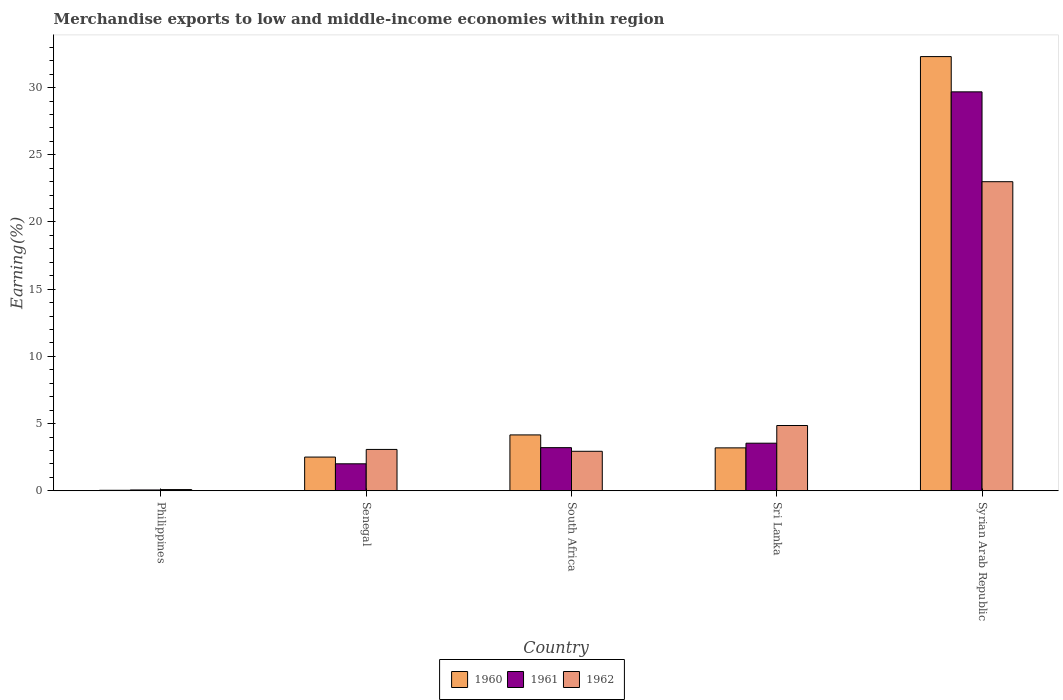How many different coloured bars are there?
Provide a short and direct response. 3. Are the number of bars per tick equal to the number of legend labels?
Your answer should be compact. Yes. Are the number of bars on each tick of the X-axis equal?
Provide a short and direct response. Yes. How many bars are there on the 5th tick from the left?
Your answer should be very brief. 3. How many bars are there on the 5th tick from the right?
Offer a very short reply. 3. What is the label of the 1st group of bars from the left?
Offer a terse response. Philippines. In how many cases, is the number of bars for a given country not equal to the number of legend labels?
Your answer should be compact. 0. What is the percentage of amount earned from merchandise exports in 1960 in South Africa?
Make the answer very short. 4.16. Across all countries, what is the maximum percentage of amount earned from merchandise exports in 1960?
Ensure brevity in your answer.  32.31. Across all countries, what is the minimum percentage of amount earned from merchandise exports in 1962?
Your answer should be very brief. 0.09. In which country was the percentage of amount earned from merchandise exports in 1962 maximum?
Ensure brevity in your answer.  Syrian Arab Republic. What is the total percentage of amount earned from merchandise exports in 1962 in the graph?
Provide a succinct answer. 33.96. What is the difference between the percentage of amount earned from merchandise exports in 1960 in Philippines and that in Sri Lanka?
Keep it short and to the point. -3.16. What is the difference between the percentage of amount earned from merchandise exports in 1960 in South Africa and the percentage of amount earned from merchandise exports in 1962 in Senegal?
Offer a terse response. 1.08. What is the average percentage of amount earned from merchandise exports in 1960 per country?
Make the answer very short. 8.44. What is the difference between the percentage of amount earned from merchandise exports of/in 1961 and percentage of amount earned from merchandise exports of/in 1960 in South Africa?
Your answer should be compact. -0.95. In how many countries, is the percentage of amount earned from merchandise exports in 1960 greater than 28 %?
Give a very brief answer. 1. What is the ratio of the percentage of amount earned from merchandise exports in 1961 in Philippines to that in Syrian Arab Republic?
Ensure brevity in your answer.  0. Is the percentage of amount earned from merchandise exports in 1960 in Senegal less than that in Syrian Arab Republic?
Your response must be concise. Yes. What is the difference between the highest and the second highest percentage of amount earned from merchandise exports in 1961?
Give a very brief answer. -0.33. What is the difference between the highest and the lowest percentage of amount earned from merchandise exports in 1960?
Offer a very short reply. 32.27. In how many countries, is the percentage of amount earned from merchandise exports in 1962 greater than the average percentage of amount earned from merchandise exports in 1962 taken over all countries?
Offer a terse response. 1. What does the 2nd bar from the left in Syrian Arab Republic represents?
Give a very brief answer. 1961. What does the 2nd bar from the right in Syrian Arab Republic represents?
Provide a succinct answer. 1961. Are all the bars in the graph horizontal?
Make the answer very short. No. How many countries are there in the graph?
Provide a succinct answer. 5. Does the graph contain any zero values?
Make the answer very short. No. Does the graph contain grids?
Give a very brief answer. No. How many legend labels are there?
Offer a terse response. 3. How are the legend labels stacked?
Your response must be concise. Horizontal. What is the title of the graph?
Keep it short and to the point. Merchandise exports to low and middle-income economies within region. What is the label or title of the Y-axis?
Offer a very short reply. Earning(%). What is the Earning(%) of 1960 in Philippines?
Offer a terse response. 0.04. What is the Earning(%) of 1961 in Philippines?
Offer a terse response. 0.06. What is the Earning(%) of 1962 in Philippines?
Provide a short and direct response. 0.09. What is the Earning(%) of 1960 in Senegal?
Give a very brief answer. 2.51. What is the Earning(%) of 1961 in Senegal?
Make the answer very short. 2.01. What is the Earning(%) in 1962 in Senegal?
Keep it short and to the point. 3.08. What is the Earning(%) of 1960 in South Africa?
Your response must be concise. 4.16. What is the Earning(%) of 1961 in South Africa?
Offer a very short reply. 3.21. What is the Earning(%) of 1962 in South Africa?
Provide a short and direct response. 2.94. What is the Earning(%) in 1960 in Sri Lanka?
Offer a very short reply. 3.19. What is the Earning(%) of 1961 in Sri Lanka?
Give a very brief answer. 3.54. What is the Earning(%) of 1962 in Sri Lanka?
Offer a terse response. 4.86. What is the Earning(%) in 1960 in Syrian Arab Republic?
Provide a short and direct response. 32.31. What is the Earning(%) of 1961 in Syrian Arab Republic?
Make the answer very short. 29.68. What is the Earning(%) in 1962 in Syrian Arab Republic?
Your answer should be very brief. 23. Across all countries, what is the maximum Earning(%) of 1960?
Provide a succinct answer. 32.31. Across all countries, what is the maximum Earning(%) of 1961?
Provide a succinct answer. 29.68. Across all countries, what is the maximum Earning(%) of 1962?
Provide a succinct answer. 23. Across all countries, what is the minimum Earning(%) in 1960?
Provide a succinct answer. 0.04. Across all countries, what is the minimum Earning(%) of 1961?
Your answer should be very brief. 0.06. Across all countries, what is the minimum Earning(%) of 1962?
Your answer should be compact. 0.09. What is the total Earning(%) in 1960 in the graph?
Keep it short and to the point. 42.2. What is the total Earning(%) in 1961 in the graph?
Provide a short and direct response. 38.5. What is the total Earning(%) in 1962 in the graph?
Offer a very short reply. 33.96. What is the difference between the Earning(%) in 1960 in Philippines and that in Senegal?
Your response must be concise. -2.47. What is the difference between the Earning(%) of 1961 in Philippines and that in Senegal?
Provide a succinct answer. -1.95. What is the difference between the Earning(%) of 1962 in Philippines and that in Senegal?
Provide a succinct answer. -2.99. What is the difference between the Earning(%) in 1960 in Philippines and that in South Africa?
Give a very brief answer. -4.12. What is the difference between the Earning(%) in 1961 in Philippines and that in South Africa?
Give a very brief answer. -3.15. What is the difference between the Earning(%) of 1962 in Philippines and that in South Africa?
Keep it short and to the point. -2.85. What is the difference between the Earning(%) of 1960 in Philippines and that in Sri Lanka?
Your answer should be compact. -3.16. What is the difference between the Earning(%) of 1961 in Philippines and that in Sri Lanka?
Make the answer very short. -3.48. What is the difference between the Earning(%) of 1962 in Philippines and that in Sri Lanka?
Offer a very short reply. -4.77. What is the difference between the Earning(%) in 1960 in Philippines and that in Syrian Arab Republic?
Give a very brief answer. -32.27. What is the difference between the Earning(%) of 1961 in Philippines and that in Syrian Arab Republic?
Give a very brief answer. -29.62. What is the difference between the Earning(%) of 1962 in Philippines and that in Syrian Arab Republic?
Give a very brief answer. -22.91. What is the difference between the Earning(%) of 1960 in Senegal and that in South Africa?
Your answer should be very brief. -1.65. What is the difference between the Earning(%) in 1961 in Senegal and that in South Africa?
Your answer should be very brief. -1.2. What is the difference between the Earning(%) of 1962 in Senegal and that in South Africa?
Ensure brevity in your answer.  0.14. What is the difference between the Earning(%) of 1960 in Senegal and that in Sri Lanka?
Offer a terse response. -0.68. What is the difference between the Earning(%) in 1961 in Senegal and that in Sri Lanka?
Your answer should be very brief. -1.53. What is the difference between the Earning(%) of 1962 in Senegal and that in Sri Lanka?
Offer a terse response. -1.78. What is the difference between the Earning(%) in 1960 in Senegal and that in Syrian Arab Republic?
Your response must be concise. -29.8. What is the difference between the Earning(%) of 1961 in Senegal and that in Syrian Arab Republic?
Your response must be concise. -27.68. What is the difference between the Earning(%) in 1962 in Senegal and that in Syrian Arab Republic?
Ensure brevity in your answer.  -19.92. What is the difference between the Earning(%) in 1960 in South Africa and that in Sri Lanka?
Provide a short and direct response. 0.96. What is the difference between the Earning(%) in 1961 in South Africa and that in Sri Lanka?
Provide a succinct answer. -0.33. What is the difference between the Earning(%) in 1962 in South Africa and that in Sri Lanka?
Provide a short and direct response. -1.92. What is the difference between the Earning(%) in 1960 in South Africa and that in Syrian Arab Republic?
Provide a short and direct response. -28.15. What is the difference between the Earning(%) of 1961 in South Africa and that in Syrian Arab Republic?
Provide a short and direct response. -26.47. What is the difference between the Earning(%) of 1962 in South Africa and that in Syrian Arab Republic?
Make the answer very short. -20.06. What is the difference between the Earning(%) in 1960 in Sri Lanka and that in Syrian Arab Republic?
Your response must be concise. -29.11. What is the difference between the Earning(%) in 1961 in Sri Lanka and that in Syrian Arab Republic?
Ensure brevity in your answer.  -26.14. What is the difference between the Earning(%) of 1962 in Sri Lanka and that in Syrian Arab Republic?
Your answer should be very brief. -18.14. What is the difference between the Earning(%) of 1960 in Philippines and the Earning(%) of 1961 in Senegal?
Provide a short and direct response. -1.97. What is the difference between the Earning(%) of 1960 in Philippines and the Earning(%) of 1962 in Senegal?
Keep it short and to the point. -3.04. What is the difference between the Earning(%) of 1961 in Philippines and the Earning(%) of 1962 in Senegal?
Give a very brief answer. -3.02. What is the difference between the Earning(%) in 1960 in Philippines and the Earning(%) in 1961 in South Africa?
Give a very brief answer. -3.17. What is the difference between the Earning(%) of 1960 in Philippines and the Earning(%) of 1962 in South Africa?
Offer a very short reply. -2.9. What is the difference between the Earning(%) of 1961 in Philippines and the Earning(%) of 1962 in South Africa?
Make the answer very short. -2.88. What is the difference between the Earning(%) of 1960 in Philippines and the Earning(%) of 1961 in Sri Lanka?
Give a very brief answer. -3.5. What is the difference between the Earning(%) of 1960 in Philippines and the Earning(%) of 1962 in Sri Lanka?
Provide a short and direct response. -4.82. What is the difference between the Earning(%) of 1961 in Philippines and the Earning(%) of 1962 in Sri Lanka?
Your response must be concise. -4.8. What is the difference between the Earning(%) in 1960 in Philippines and the Earning(%) in 1961 in Syrian Arab Republic?
Offer a terse response. -29.65. What is the difference between the Earning(%) in 1960 in Philippines and the Earning(%) in 1962 in Syrian Arab Republic?
Your response must be concise. -22.96. What is the difference between the Earning(%) in 1961 in Philippines and the Earning(%) in 1962 in Syrian Arab Republic?
Keep it short and to the point. -22.94. What is the difference between the Earning(%) of 1960 in Senegal and the Earning(%) of 1961 in South Africa?
Your response must be concise. -0.7. What is the difference between the Earning(%) of 1960 in Senegal and the Earning(%) of 1962 in South Africa?
Ensure brevity in your answer.  -0.43. What is the difference between the Earning(%) in 1961 in Senegal and the Earning(%) in 1962 in South Africa?
Keep it short and to the point. -0.93. What is the difference between the Earning(%) of 1960 in Senegal and the Earning(%) of 1961 in Sri Lanka?
Your answer should be compact. -1.03. What is the difference between the Earning(%) in 1960 in Senegal and the Earning(%) in 1962 in Sri Lanka?
Ensure brevity in your answer.  -2.35. What is the difference between the Earning(%) of 1961 in Senegal and the Earning(%) of 1962 in Sri Lanka?
Provide a short and direct response. -2.85. What is the difference between the Earning(%) of 1960 in Senegal and the Earning(%) of 1961 in Syrian Arab Republic?
Your answer should be compact. -27.17. What is the difference between the Earning(%) in 1960 in Senegal and the Earning(%) in 1962 in Syrian Arab Republic?
Your answer should be compact. -20.49. What is the difference between the Earning(%) in 1961 in Senegal and the Earning(%) in 1962 in Syrian Arab Republic?
Your answer should be compact. -20.99. What is the difference between the Earning(%) in 1960 in South Africa and the Earning(%) in 1961 in Sri Lanka?
Ensure brevity in your answer.  0.62. What is the difference between the Earning(%) of 1960 in South Africa and the Earning(%) of 1962 in Sri Lanka?
Provide a succinct answer. -0.7. What is the difference between the Earning(%) in 1961 in South Africa and the Earning(%) in 1962 in Sri Lanka?
Give a very brief answer. -1.65. What is the difference between the Earning(%) of 1960 in South Africa and the Earning(%) of 1961 in Syrian Arab Republic?
Your response must be concise. -25.53. What is the difference between the Earning(%) in 1960 in South Africa and the Earning(%) in 1962 in Syrian Arab Republic?
Your answer should be compact. -18.84. What is the difference between the Earning(%) of 1961 in South Africa and the Earning(%) of 1962 in Syrian Arab Republic?
Ensure brevity in your answer.  -19.79. What is the difference between the Earning(%) in 1960 in Sri Lanka and the Earning(%) in 1961 in Syrian Arab Republic?
Make the answer very short. -26.49. What is the difference between the Earning(%) in 1960 in Sri Lanka and the Earning(%) in 1962 in Syrian Arab Republic?
Keep it short and to the point. -19.8. What is the difference between the Earning(%) in 1961 in Sri Lanka and the Earning(%) in 1962 in Syrian Arab Republic?
Your answer should be compact. -19.46. What is the average Earning(%) of 1960 per country?
Your answer should be compact. 8.44. What is the average Earning(%) in 1961 per country?
Give a very brief answer. 7.7. What is the average Earning(%) of 1962 per country?
Make the answer very short. 6.79. What is the difference between the Earning(%) of 1960 and Earning(%) of 1961 in Philippines?
Offer a very short reply. -0.02. What is the difference between the Earning(%) in 1960 and Earning(%) in 1962 in Philippines?
Your response must be concise. -0.05. What is the difference between the Earning(%) of 1961 and Earning(%) of 1962 in Philippines?
Your answer should be very brief. -0.03. What is the difference between the Earning(%) of 1960 and Earning(%) of 1961 in Senegal?
Make the answer very short. 0.5. What is the difference between the Earning(%) in 1960 and Earning(%) in 1962 in Senegal?
Give a very brief answer. -0.57. What is the difference between the Earning(%) of 1961 and Earning(%) of 1962 in Senegal?
Keep it short and to the point. -1.07. What is the difference between the Earning(%) of 1960 and Earning(%) of 1961 in South Africa?
Your response must be concise. 0.95. What is the difference between the Earning(%) in 1960 and Earning(%) in 1962 in South Africa?
Offer a terse response. 1.22. What is the difference between the Earning(%) in 1961 and Earning(%) in 1962 in South Africa?
Keep it short and to the point. 0.27. What is the difference between the Earning(%) in 1960 and Earning(%) in 1961 in Sri Lanka?
Ensure brevity in your answer.  -0.35. What is the difference between the Earning(%) of 1960 and Earning(%) of 1962 in Sri Lanka?
Your answer should be very brief. -1.66. What is the difference between the Earning(%) in 1961 and Earning(%) in 1962 in Sri Lanka?
Provide a succinct answer. -1.32. What is the difference between the Earning(%) of 1960 and Earning(%) of 1961 in Syrian Arab Republic?
Make the answer very short. 2.62. What is the difference between the Earning(%) in 1960 and Earning(%) in 1962 in Syrian Arab Republic?
Give a very brief answer. 9.31. What is the difference between the Earning(%) of 1961 and Earning(%) of 1962 in Syrian Arab Republic?
Offer a terse response. 6.68. What is the ratio of the Earning(%) in 1960 in Philippines to that in Senegal?
Offer a terse response. 0.01. What is the ratio of the Earning(%) of 1961 in Philippines to that in Senegal?
Provide a succinct answer. 0.03. What is the ratio of the Earning(%) of 1962 in Philippines to that in Senegal?
Make the answer very short. 0.03. What is the ratio of the Earning(%) in 1960 in Philippines to that in South Africa?
Ensure brevity in your answer.  0.01. What is the ratio of the Earning(%) in 1961 in Philippines to that in South Africa?
Make the answer very short. 0.02. What is the ratio of the Earning(%) in 1962 in Philippines to that in South Africa?
Your answer should be very brief. 0.03. What is the ratio of the Earning(%) in 1960 in Philippines to that in Sri Lanka?
Offer a terse response. 0.01. What is the ratio of the Earning(%) in 1961 in Philippines to that in Sri Lanka?
Your response must be concise. 0.02. What is the ratio of the Earning(%) in 1962 in Philippines to that in Sri Lanka?
Give a very brief answer. 0.02. What is the ratio of the Earning(%) of 1960 in Philippines to that in Syrian Arab Republic?
Ensure brevity in your answer.  0. What is the ratio of the Earning(%) of 1961 in Philippines to that in Syrian Arab Republic?
Make the answer very short. 0. What is the ratio of the Earning(%) of 1962 in Philippines to that in Syrian Arab Republic?
Make the answer very short. 0. What is the ratio of the Earning(%) of 1960 in Senegal to that in South Africa?
Keep it short and to the point. 0.6. What is the ratio of the Earning(%) in 1961 in Senegal to that in South Africa?
Provide a succinct answer. 0.63. What is the ratio of the Earning(%) of 1962 in Senegal to that in South Africa?
Ensure brevity in your answer.  1.05. What is the ratio of the Earning(%) of 1960 in Senegal to that in Sri Lanka?
Offer a very short reply. 0.79. What is the ratio of the Earning(%) in 1961 in Senegal to that in Sri Lanka?
Your answer should be very brief. 0.57. What is the ratio of the Earning(%) of 1962 in Senegal to that in Sri Lanka?
Offer a very short reply. 0.63. What is the ratio of the Earning(%) of 1960 in Senegal to that in Syrian Arab Republic?
Offer a very short reply. 0.08. What is the ratio of the Earning(%) in 1961 in Senegal to that in Syrian Arab Republic?
Your answer should be compact. 0.07. What is the ratio of the Earning(%) of 1962 in Senegal to that in Syrian Arab Republic?
Provide a succinct answer. 0.13. What is the ratio of the Earning(%) of 1960 in South Africa to that in Sri Lanka?
Provide a succinct answer. 1.3. What is the ratio of the Earning(%) in 1961 in South Africa to that in Sri Lanka?
Your answer should be very brief. 0.91. What is the ratio of the Earning(%) in 1962 in South Africa to that in Sri Lanka?
Ensure brevity in your answer.  0.6. What is the ratio of the Earning(%) of 1960 in South Africa to that in Syrian Arab Republic?
Offer a terse response. 0.13. What is the ratio of the Earning(%) in 1961 in South Africa to that in Syrian Arab Republic?
Keep it short and to the point. 0.11. What is the ratio of the Earning(%) of 1962 in South Africa to that in Syrian Arab Republic?
Provide a short and direct response. 0.13. What is the ratio of the Earning(%) of 1960 in Sri Lanka to that in Syrian Arab Republic?
Your response must be concise. 0.1. What is the ratio of the Earning(%) of 1961 in Sri Lanka to that in Syrian Arab Republic?
Your answer should be compact. 0.12. What is the ratio of the Earning(%) in 1962 in Sri Lanka to that in Syrian Arab Republic?
Your answer should be compact. 0.21. What is the difference between the highest and the second highest Earning(%) of 1960?
Give a very brief answer. 28.15. What is the difference between the highest and the second highest Earning(%) in 1961?
Your response must be concise. 26.14. What is the difference between the highest and the second highest Earning(%) of 1962?
Your answer should be compact. 18.14. What is the difference between the highest and the lowest Earning(%) in 1960?
Make the answer very short. 32.27. What is the difference between the highest and the lowest Earning(%) of 1961?
Provide a short and direct response. 29.62. What is the difference between the highest and the lowest Earning(%) of 1962?
Keep it short and to the point. 22.91. 